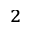Convert formula to latex. <formula><loc_0><loc_0><loc_500><loc_500>^ { 2 }</formula> 